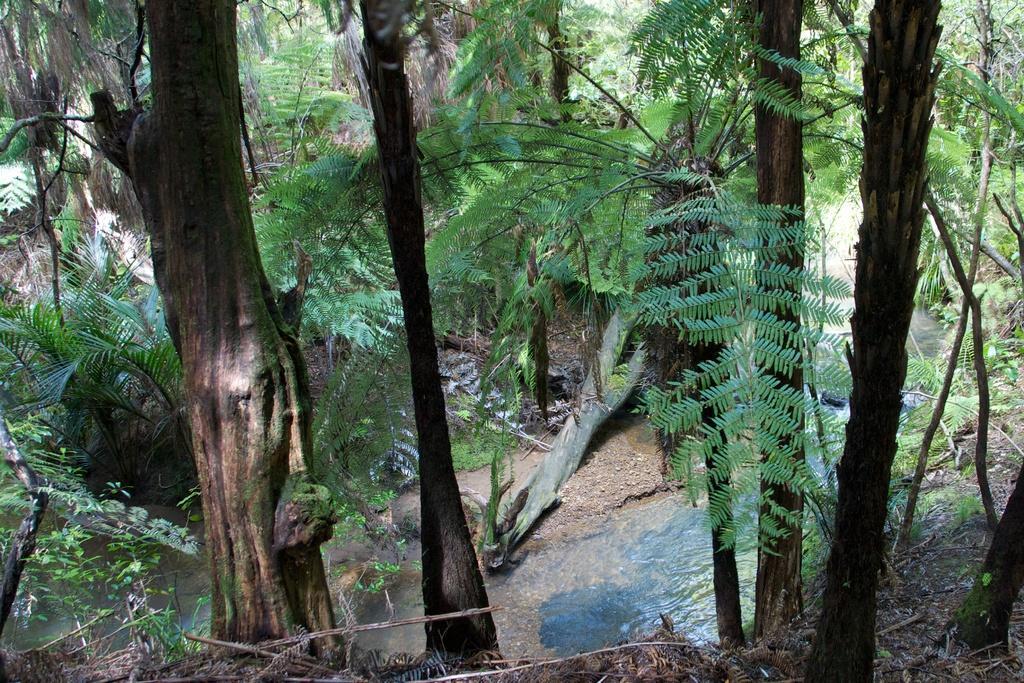Describe this image in one or two sentences. In this picture there is a view of the forest. In the front we can see tree trunk. Behind there are some green trees. 